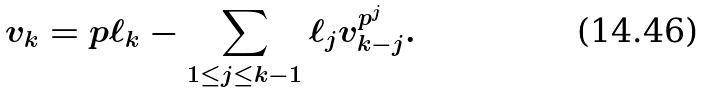Convert formula to latex. <formula><loc_0><loc_0><loc_500><loc_500>v _ { k } = p \ell _ { k } - \sum _ { 1 \leq j \leq k - 1 } \ell _ { j } v _ { k - j } ^ { p ^ { j } } .</formula> 